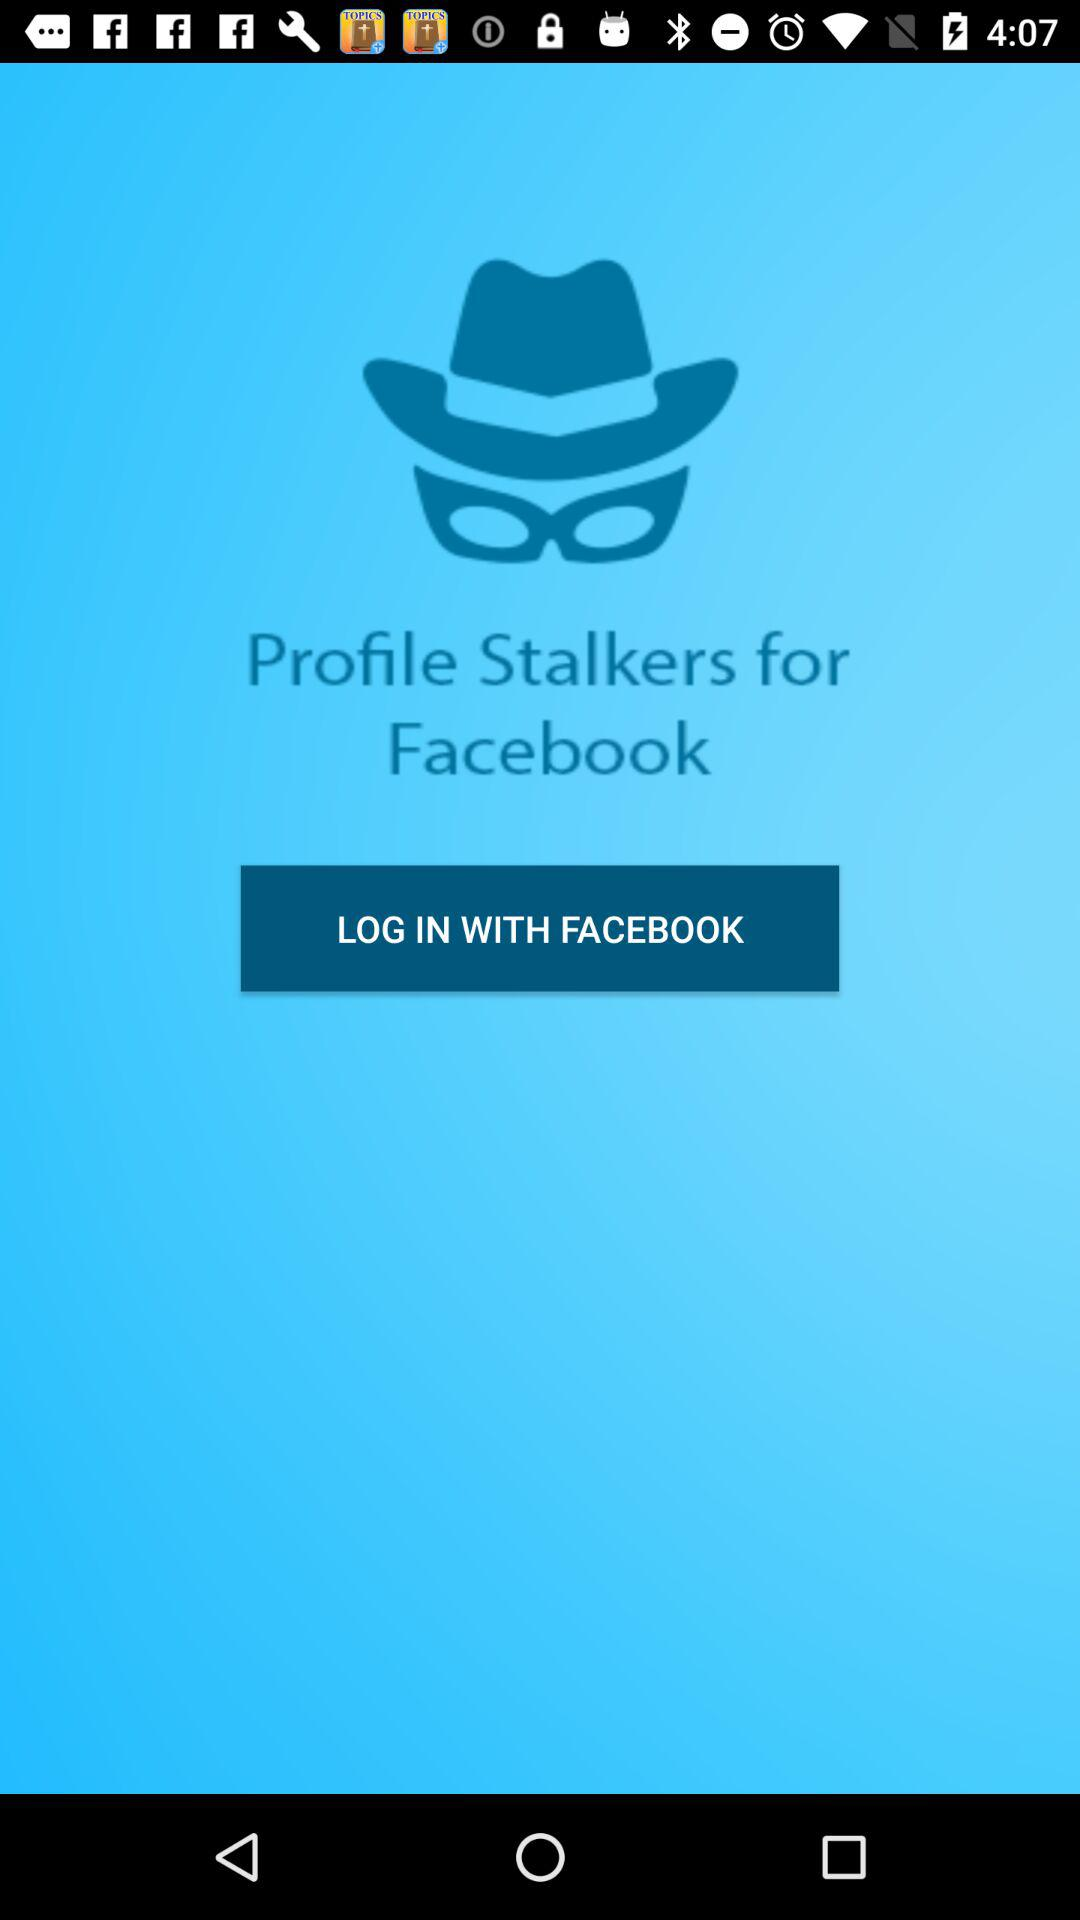When was the last login?
When the provided information is insufficient, respond with <no answer>. <no answer> 